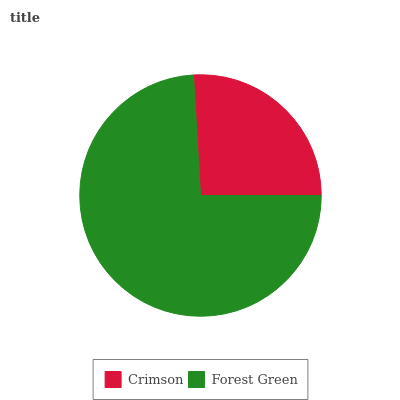Is Crimson the minimum?
Answer yes or no. Yes. Is Forest Green the maximum?
Answer yes or no. Yes. Is Forest Green the minimum?
Answer yes or no. No. Is Forest Green greater than Crimson?
Answer yes or no. Yes. Is Crimson less than Forest Green?
Answer yes or no. Yes. Is Crimson greater than Forest Green?
Answer yes or no. No. Is Forest Green less than Crimson?
Answer yes or no. No. Is Forest Green the high median?
Answer yes or no. Yes. Is Crimson the low median?
Answer yes or no. Yes. Is Crimson the high median?
Answer yes or no. No. Is Forest Green the low median?
Answer yes or no. No. 